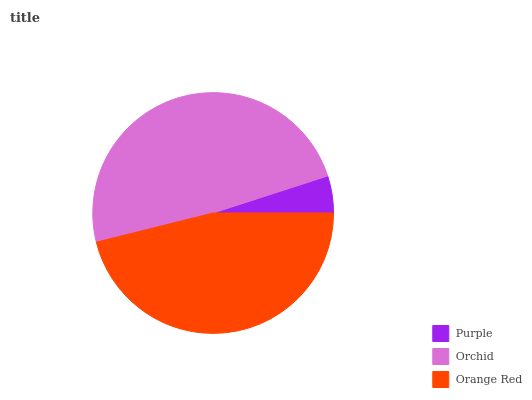Is Purple the minimum?
Answer yes or no. Yes. Is Orchid the maximum?
Answer yes or no. Yes. Is Orange Red the minimum?
Answer yes or no. No. Is Orange Red the maximum?
Answer yes or no. No. Is Orchid greater than Orange Red?
Answer yes or no. Yes. Is Orange Red less than Orchid?
Answer yes or no. Yes. Is Orange Red greater than Orchid?
Answer yes or no. No. Is Orchid less than Orange Red?
Answer yes or no. No. Is Orange Red the high median?
Answer yes or no. Yes. Is Orange Red the low median?
Answer yes or no. Yes. Is Purple the high median?
Answer yes or no. No. Is Purple the low median?
Answer yes or no. No. 